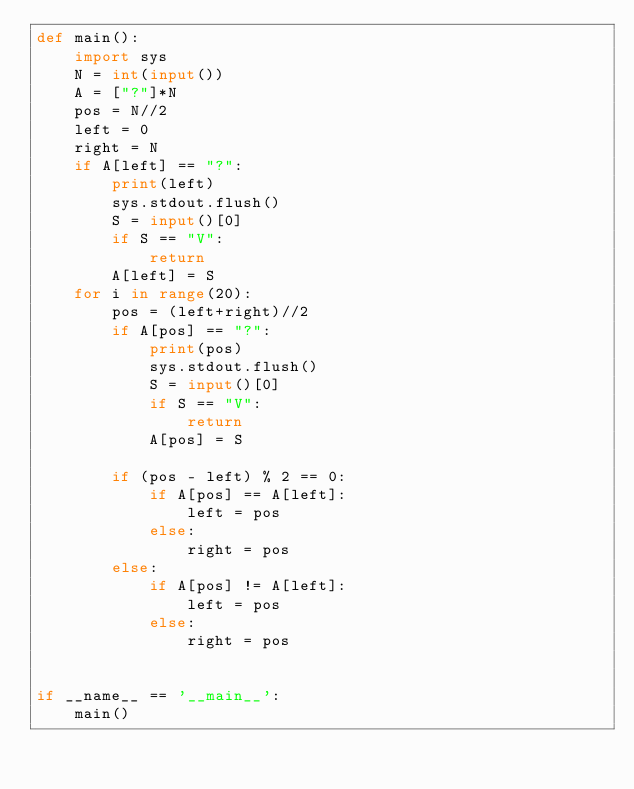Convert code to text. <code><loc_0><loc_0><loc_500><loc_500><_Python_>def main():
    import sys
    N = int(input())
    A = ["?"]*N
    pos = N//2
    left = 0
    right = N
    if A[left] == "?":
        print(left)
        sys.stdout.flush()
        S = input()[0]
        if S == "V":
            return
        A[left] = S
    for i in range(20):
        pos = (left+right)//2
        if A[pos] == "?":
            print(pos)
            sys.stdout.flush()
            S = input()[0]
            if S == "V":
                return
            A[pos] = S

        if (pos - left) % 2 == 0:
            if A[pos] == A[left]:
                left = pos
            else:
                right = pos
        else:
            if A[pos] != A[left]:
                left = pos
            else:
                right = pos


if __name__ == '__main__':
    main()
</code> 